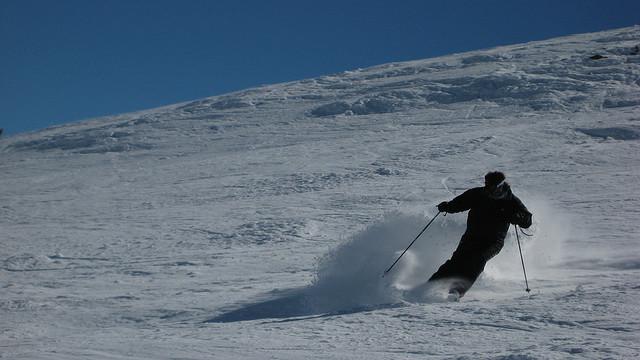Is the skier a cross country skier?
Write a very short answer. No. Are they surfing?
Short answer required. No. What is the person doing?
Write a very short answer. Skiing. What is the man riding on?
Quick response, please. Skis. What is the person skiing on?
Give a very brief answer. Snow. What sport is this?
Answer briefly. Skiing. What's the person holding?
Quick response, please. Ski poles. 